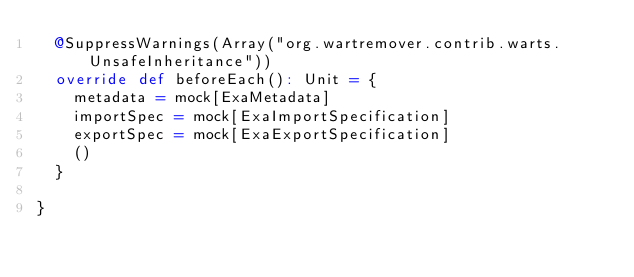Convert code to text. <code><loc_0><loc_0><loc_500><loc_500><_Scala_>  @SuppressWarnings(Array("org.wartremover.contrib.warts.UnsafeInheritance"))
  override def beforeEach(): Unit = {
    metadata = mock[ExaMetadata]
    importSpec = mock[ExaImportSpecification]
    exportSpec = mock[ExaExportSpecification]
    ()
  }

}
</code> 